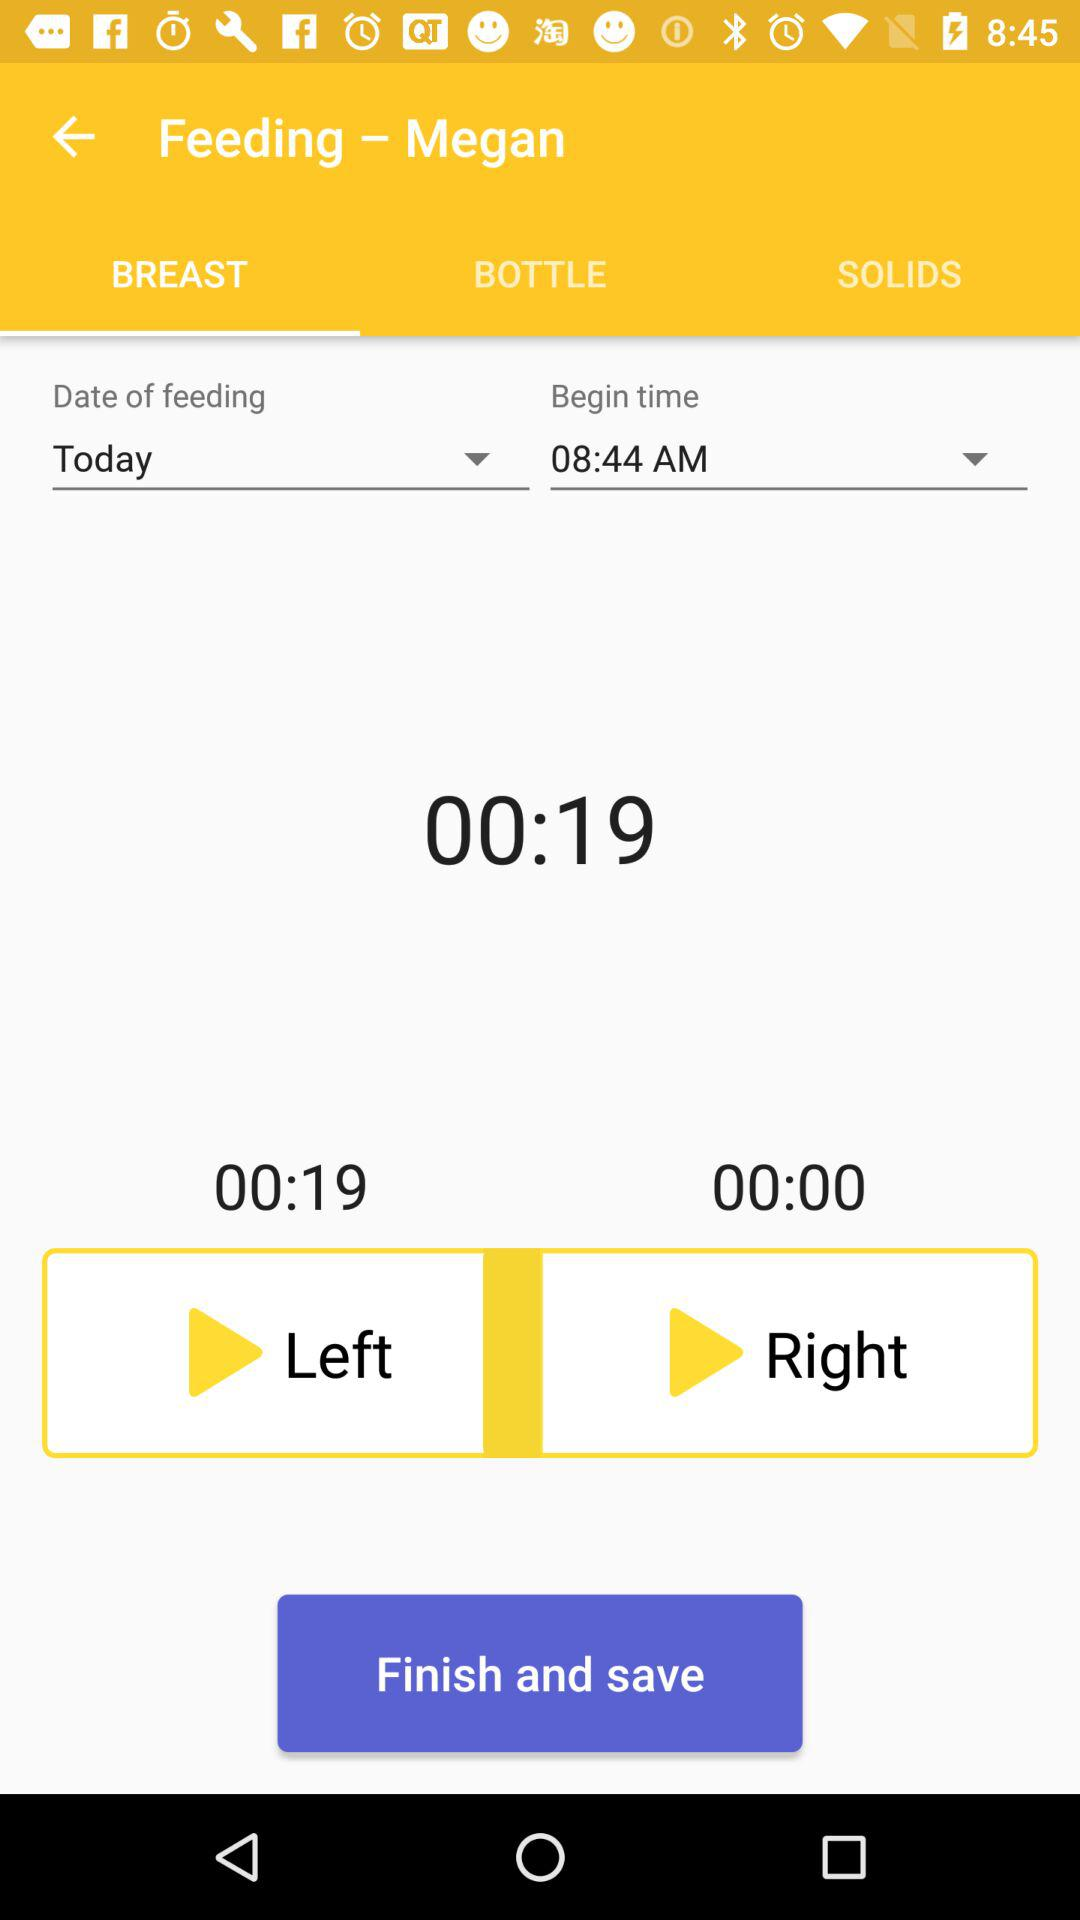What is the "Begin time"? The "Begin time" is 08:44 AM. 